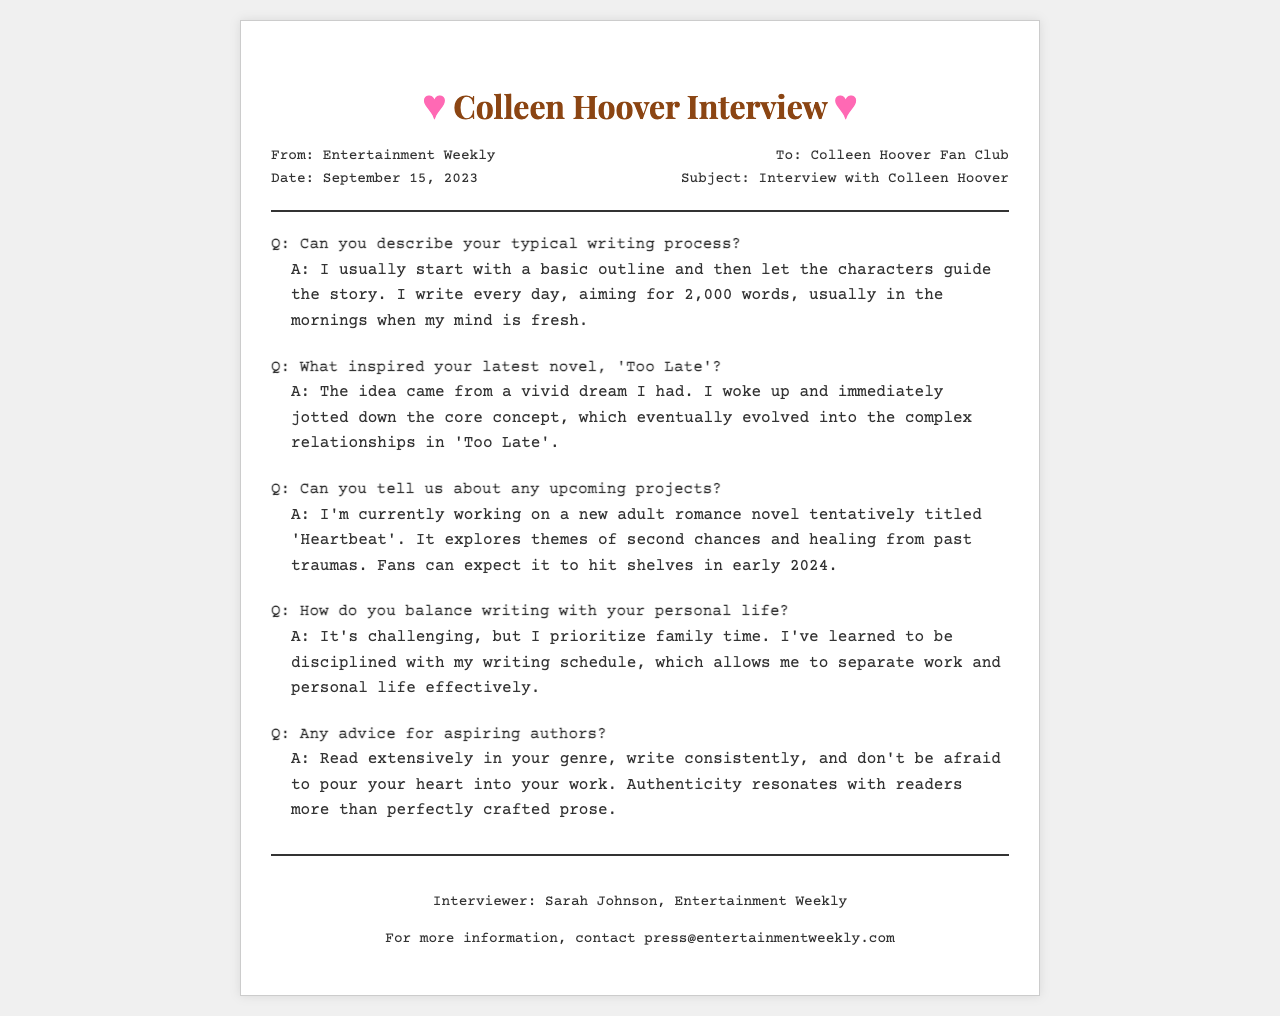What is the title of Colleen Hoover's latest novel? The title of her latest novel is mentioned in the document as 'Too Late'.
Answer: 'Too Late' What is Colleen Hoover's writing goal per day? In the document, it states that she aims to write 2,000 words every day.
Answer: 2,000 words When is Colleen Hoover's upcoming novel expected to be released? The expected release time for her upcoming novel is noted as early 2024.
Answer: early 2024 Who conducted the interview with Colleen Hoover? The document specifies that the interviewer is Sarah Johnson from Entertainment Weekly.
Answer: Sarah Johnson What themes does Colleen Hoover's new novel 'Heartbeat' explore? The document highlights that 'Heartbeat' explores themes of second chances and healing from past traumas.
Answer: second chances and healing from past traumas How does Colleen Hoover manage writing with personal life? She mentions in the document that she prioritizes family time and has learned to be disciplined with her writing schedule.
Answer: prioritizes family time What was the source of inspiration for 'Too Late'? Colleen Hoover describes in the document that the idea came from a vivid dream she had.
Answer: a vivid dream Which publication sent the fax? The document indicates that the fax is from Entertainment Weekly.
Answer: Entertainment Weekly What is Colleen Hoover's advice for aspiring authors? The document states that she advises to read extensively in your genre, write consistently, and be authentic.
Answer: read extensively in your genre, write consistently, and be authentic 